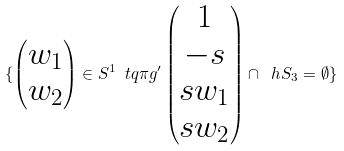<formula> <loc_0><loc_0><loc_500><loc_500>\{ \begin{pmatrix} w _ { 1 } \\ w _ { 2 } \end{pmatrix} \in S ^ { 1 } \ t q \pi g ^ { \prime } \begin{pmatrix} 1 \\ - s \\ s w _ { 1 } \\ s w _ { 2 } \end{pmatrix} \cap \ h S _ { 3 } = \emptyset \}</formula> 